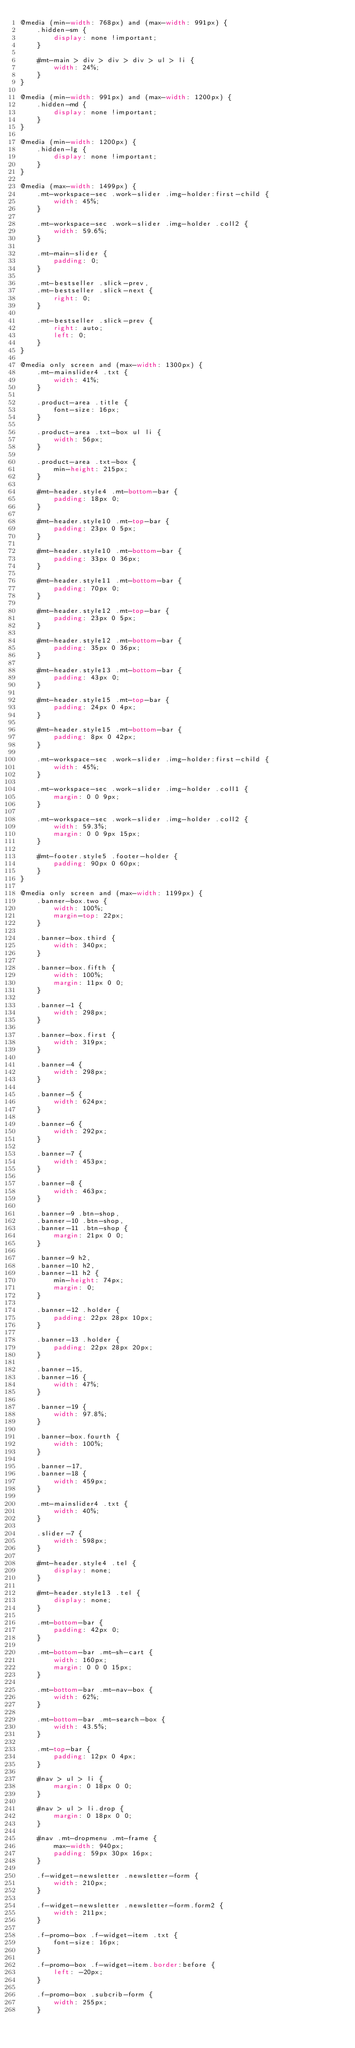Convert code to text. <code><loc_0><loc_0><loc_500><loc_500><_CSS_>@media (min-width: 768px) and (max-width: 991px) {
    .hidden-sm {
        display: none !important;
    }

    #mt-main > div > div > div > ul > li {
        width: 24%;
    }
}

@media (min-width: 991px) and (max-width: 1200px) {
    .hidden-md {
        display: none !important;
    }
}

@media (min-width: 1200px) {
    .hidden-lg {
        display: none !important;
    }
}

@media (max-width: 1499px) {
    .mt-workspace-sec .work-slider .img-holder:first-child {
        width: 45%;
    }

    .mt-workspace-sec .work-slider .img-holder .coll2 {
        width: 59.6%;
    }

    .mt-main-slider {
        padding: 0;
    }

    .mt-bestseller .slick-prev,
    .mt-bestseller .slick-next {
        right: 0;
    }

    .mt-bestseller .slick-prev {
        right: auto;
        left: 0;
    }
}

@media only screen and (max-width: 1300px) {
    .mt-mainslider4 .txt {
        width: 41%;
    }

    .product-area .title {
        font-size: 16px;
    }

    .product-area .txt-box ul li {
        width: 56px;
    }

    .product-area .txt-box {
        min-height: 215px;
    }

    #mt-header.style4 .mt-bottom-bar {
        padding: 18px 0;
    }

    #mt-header.style10 .mt-top-bar {
        padding: 23px 0 5px;
    }

    #mt-header.style10 .mt-bottom-bar {
        padding: 33px 0 36px;
    }

    #mt-header.style11 .mt-bottom-bar {
        padding: 70px 0;
    }

    #mt-header.style12 .mt-top-bar {
        padding: 23px 0 5px;
    }

    #mt-header.style12 .mt-bottom-bar {
        padding: 35px 0 36px;
    }

    #mt-header.style13 .mt-bottom-bar {
        padding: 43px 0;
    }

    #mt-header.style15 .mt-top-bar {
        padding: 24px 0 4px;
    }

    #mt-header.style15 .mt-bottom-bar {
        padding: 8px 0 42px;
    }

    .mt-workspace-sec .work-slider .img-holder:first-child {
        width: 45%;
    }

    .mt-workspace-sec .work-slider .img-holder .coll1 {
        margin: 0 0 9px;
    }

    .mt-workspace-sec .work-slider .img-holder .coll2 {
        width: 59.3%;
        margin: 0 0 9px 15px;
    }

    #mt-footer.style5 .footer-holder {
        padding: 90px 0 60px;
    }
}

@media only screen and (max-width: 1199px) {
    .banner-box.two {
        width: 100%;
        margin-top: 22px;
    }

    .banner-box.third {
        width: 340px;
    }

    .banner-box.fifth {
        width: 100%;
        margin: 11px 0 0;
    }

    .banner-1 {
        width: 298px;
    }

    .banner-box.first {
        width: 319px;
    }

    .banner-4 {
        width: 298px;
    }

    .banner-5 {
        width: 624px;
    }

    .banner-6 {
        width: 292px;
    }

    .banner-7 {
        width: 453px;
    }

    .banner-8 {
        width: 463px;
    }

    .banner-9 .btn-shop,
    .banner-10 .btn-shop,
    .banner-11 .btn-shop {
        margin: 21px 0 0;
    }

    .banner-9 h2,
    .banner-10 h2,
    .banner-11 h2 {
        min-height: 74px;
        margin: 0;
    }

    .banner-12 .holder {
        padding: 22px 28px 10px;
    }

    .banner-13 .holder {
        padding: 22px 28px 20px;
    }

    .banner-15,
    .banner-16 {
        width: 47%;
    }

    .banner-19 {
        width: 97.8%;
    }

    .banner-box.fourth {
        width: 100%;
    }

    .banner-17,
    .banner-18 {
        width: 459px;
    }

    .mt-mainslider4 .txt {
        width: 40%;
    }

    .slider-7 {
        width: 598px;
    }

    #mt-header.style4 .tel {
        display: none;
    }

    #mt-header.style13 .tel {
        display: none;
    }

    .mt-bottom-bar {
        padding: 42px 0;
    }

    .mt-bottom-bar .mt-sh-cart {
        width: 160px;
        margin: 0 0 0 15px;
    }

    .mt-bottom-bar .mt-nav-box {
        width: 62%;
    }

    .mt-bottom-bar .mt-search-box {
        width: 43.5%;
    }

    .mt-top-bar {
        padding: 12px 0 4px;
    }

    #nav > ul > li {
        margin: 0 18px 0 0;
    }

    #nav > ul > li.drop {
        margin: 0 18px 0 0;
    }

    #nav .mt-dropmenu .mt-frame {
        max-width: 940px;
        padding: 59px 30px 16px;
    }

    .f-widget-newsletter .newsletter-form {
        width: 210px;
    }

    .f-widget-newsletter .newsletter-form.form2 {
        width: 211px;
    }

    .f-promo-box .f-widget-item .txt {
        font-size: 16px;
    }

    .f-promo-box .f-widget-item.border:before {
        left: -20px;
    }

    .f-promo-box .subcrib-form {
        width: 255px;
    }
</code> 